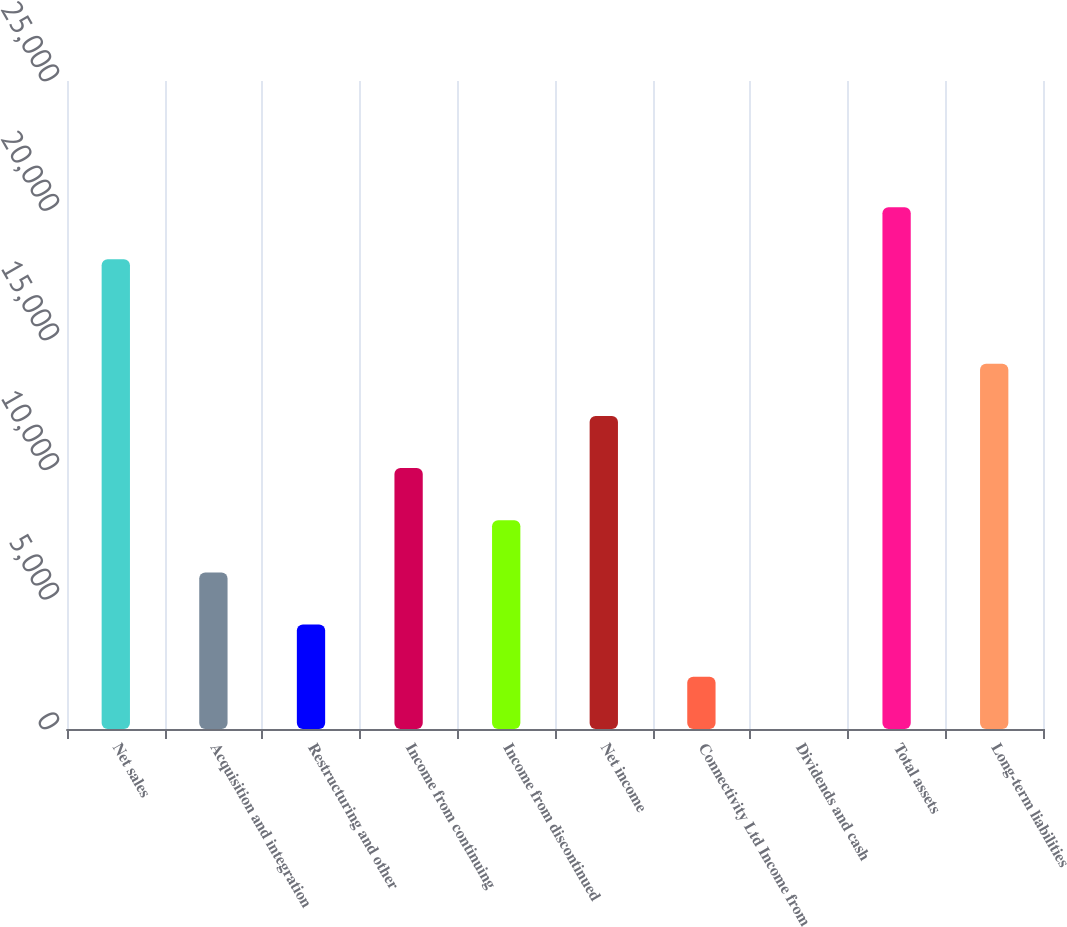Convert chart. <chart><loc_0><loc_0><loc_500><loc_500><bar_chart><fcel>Net sales<fcel>Acquisition and integration<fcel>Restructuring and other<fcel>Income from continuing<fcel>Income from discontinued<fcel>Net income<fcel>Connectivity Ltd Income from<fcel>Dividends and cash<fcel>Total assets<fcel>Long-term liabilities<nl><fcel>18118.9<fcel>6040.35<fcel>4027.26<fcel>10066.5<fcel>8053.44<fcel>12079.6<fcel>2014.17<fcel>1.08<fcel>20132<fcel>14092.7<nl></chart> 